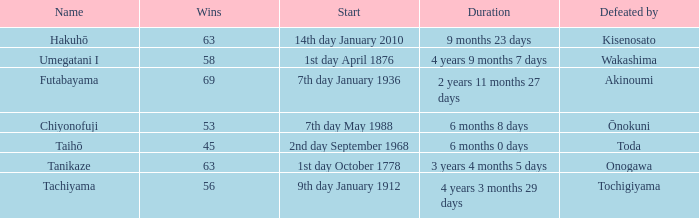How many wins were held before being defeated by toda? 1.0. 